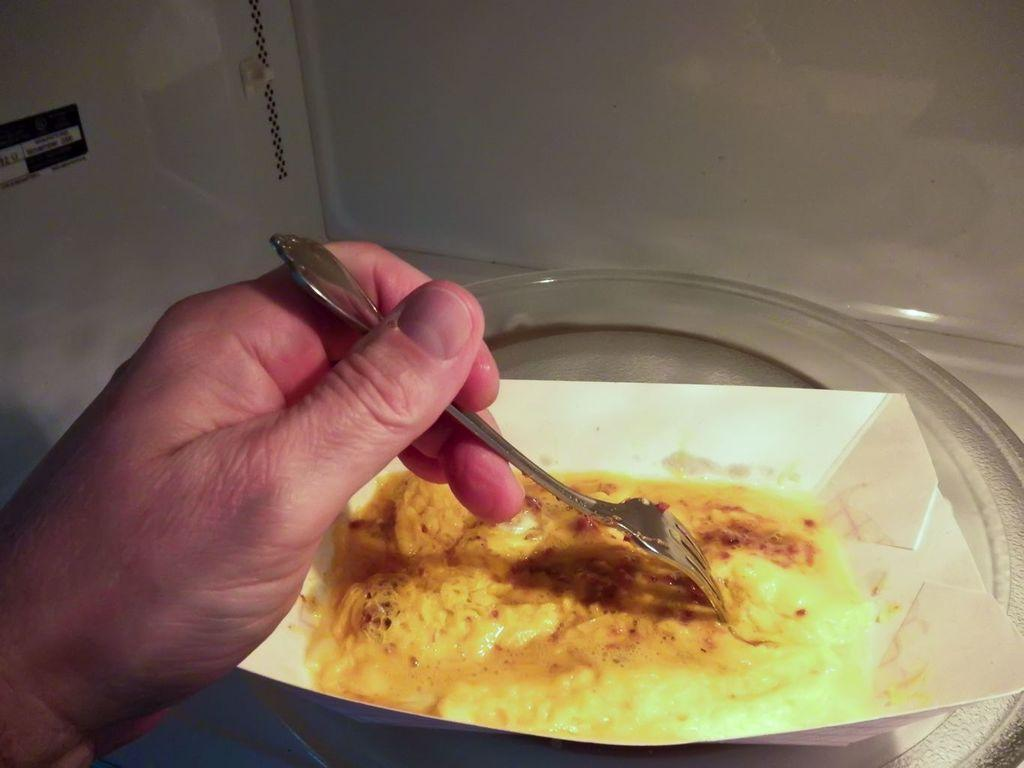What is the edible item in the image? The specific edible item is not mentioned, but it is present in the image. Can you describe the person in the image? There is a person in the image, and they are holding a fork in their left hand. What type of operation is the person performing in the image? There is no operation being performed in the image; the person is simply holding a fork in their left hand. 